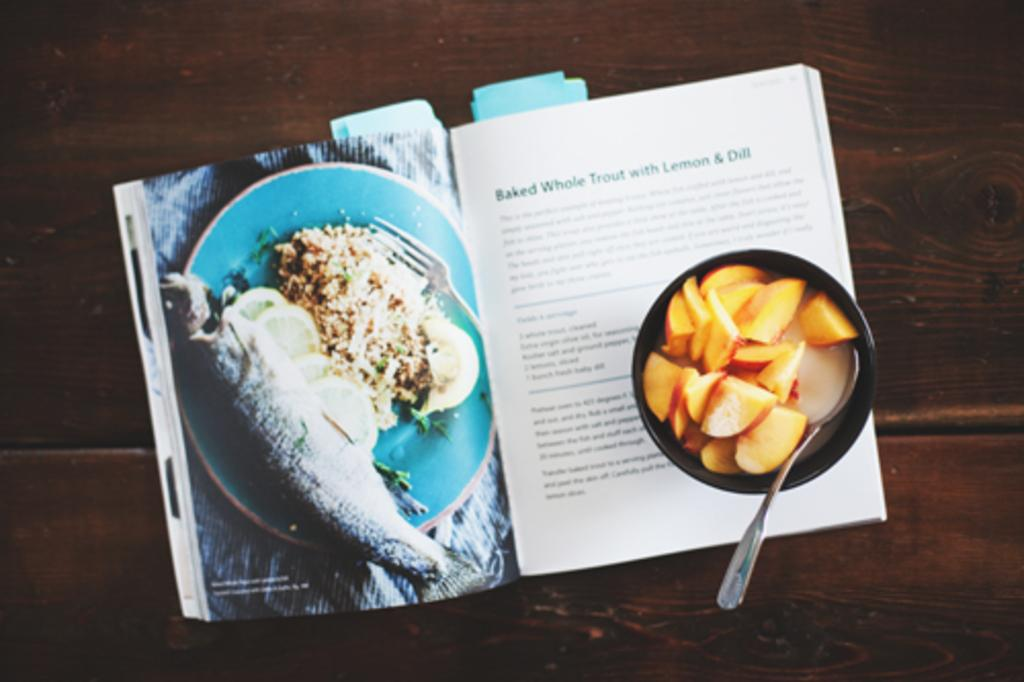<image>
Describe the image concisely. An open cookbook on a page with a recipe on Baked Whole Trout with Lemon & Dill. 